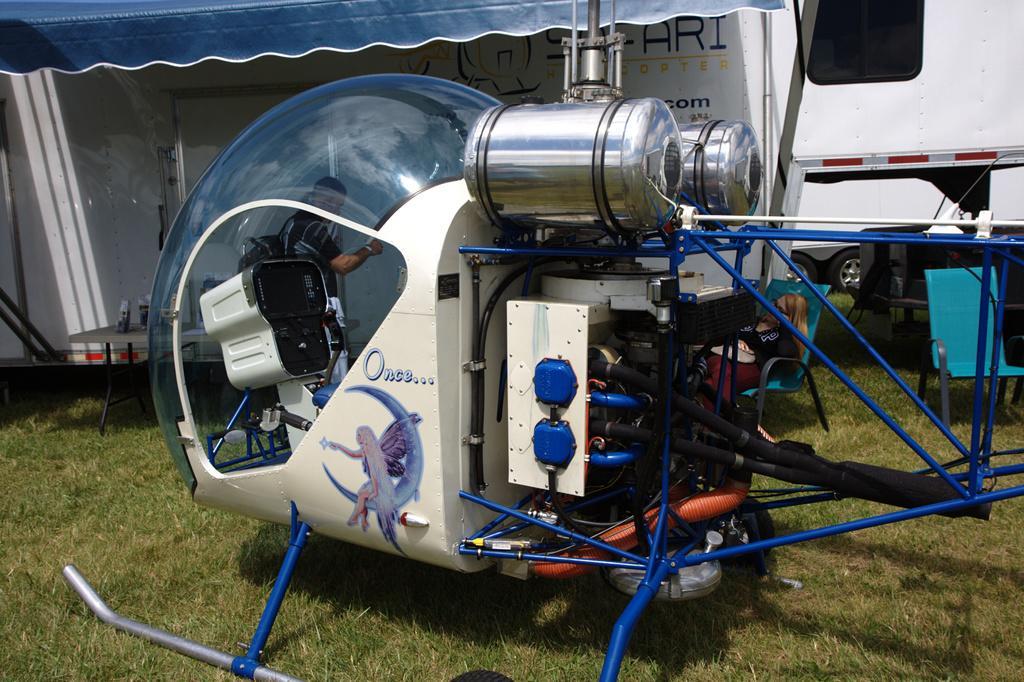Can you describe this image briefly? This image consists of some equipment. There is a person in the middle. There is something like tent at the top. It looks like a helicopter. There is a vehicle at the top. 